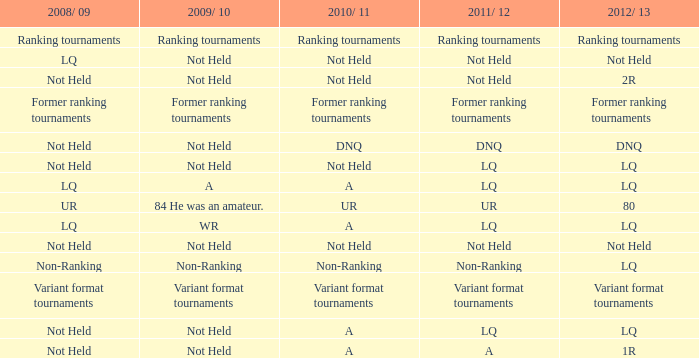When 2011/ 12 is non-ranking, what is the 2009/ 10? Non-Ranking. 